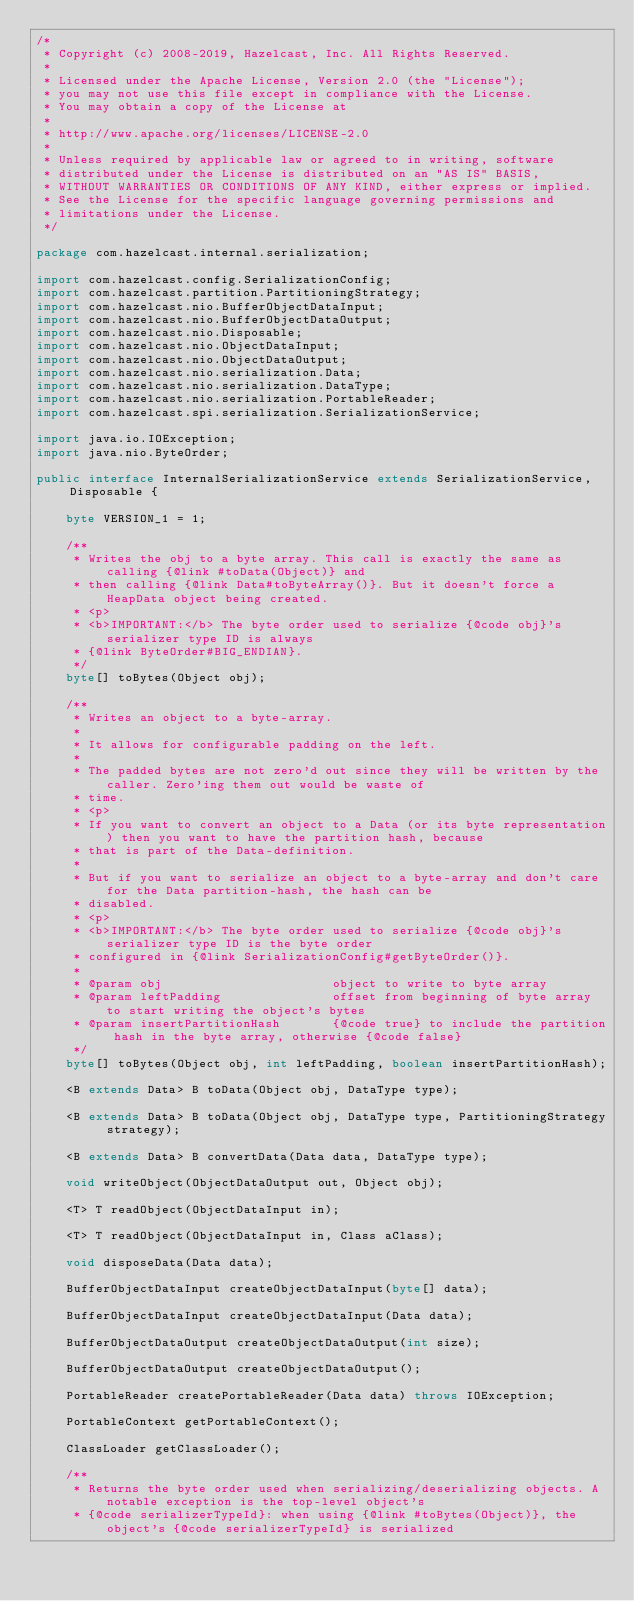Convert code to text. <code><loc_0><loc_0><loc_500><loc_500><_Java_>/*
 * Copyright (c) 2008-2019, Hazelcast, Inc. All Rights Reserved.
 *
 * Licensed under the Apache License, Version 2.0 (the "License");
 * you may not use this file except in compliance with the License.
 * You may obtain a copy of the License at
 *
 * http://www.apache.org/licenses/LICENSE-2.0
 *
 * Unless required by applicable law or agreed to in writing, software
 * distributed under the License is distributed on an "AS IS" BASIS,
 * WITHOUT WARRANTIES OR CONDITIONS OF ANY KIND, either express or implied.
 * See the License for the specific language governing permissions and
 * limitations under the License.
 */

package com.hazelcast.internal.serialization;

import com.hazelcast.config.SerializationConfig;
import com.hazelcast.partition.PartitioningStrategy;
import com.hazelcast.nio.BufferObjectDataInput;
import com.hazelcast.nio.BufferObjectDataOutput;
import com.hazelcast.nio.Disposable;
import com.hazelcast.nio.ObjectDataInput;
import com.hazelcast.nio.ObjectDataOutput;
import com.hazelcast.nio.serialization.Data;
import com.hazelcast.nio.serialization.DataType;
import com.hazelcast.nio.serialization.PortableReader;
import com.hazelcast.spi.serialization.SerializationService;

import java.io.IOException;
import java.nio.ByteOrder;

public interface InternalSerializationService extends SerializationService, Disposable {

    byte VERSION_1 = 1;

    /**
     * Writes the obj to a byte array. This call is exactly the same as calling {@link #toData(Object)} and
     * then calling {@link Data#toByteArray()}. But it doesn't force a HeapData object being created.
     * <p>
     * <b>IMPORTANT:</b> The byte order used to serialize {@code obj}'s serializer type ID is always
     * {@link ByteOrder#BIG_ENDIAN}.
     */
    byte[] toBytes(Object obj);

    /**
     * Writes an object to a byte-array.
     *
     * It allows for configurable padding on the left.
     *
     * The padded bytes are not zero'd out since they will be written by the caller. Zero'ing them out would be waste of
     * time.
     * <p>
     * If you want to convert an object to a Data (or its byte representation) then you want to have the partition hash, because
     * that is part of the Data-definition.
     *
     * But if you want to serialize an object to a byte-array and don't care for the Data partition-hash, the hash can be
     * disabled.
     * <p>
     * <b>IMPORTANT:</b> The byte order used to serialize {@code obj}'s serializer type ID is the byte order
     * configured in {@link SerializationConfig#getByteOrder()}.
     *
     * @param obj                       object to write to byte array
     * @param leftPadding               offset from beginning of byte array to start writing the object's bytes
     * @param insertPartitionHash       {@code true} to include the partition hash in the byte array, otherwise {@code false}
     */
    byte[] toBytes(Object obj, int leftPadding, boolean insertPartitionHash);

    <B extends Data> B toData(Object obj, DataType type);

    <B extends Data> B toData(Object obj, DataType type, PartitioningStrategy strategy);

    <B extends Data> B convertData(Data data, DataType type);

    void writeObject(ObjectDataOutput out, Object obj);

    <T> T readObject(ObjectDataInput in);

    <T> T readObject(ObjectDataInput in, Class aClass);

    void disposeData(Data data);

    BufferObjectDataInput createObjectDataInput(byte[] data);

    BufferObjectDataInput createObjectDataInput(Data data);

    BufferObjectDataOutput createObjectDataOutput(int size);

    BufferObjectDataOutput createObjectDataOutput();

    PortableReader createPortableReader(Data data) throws IOException;

    PortableContext getPortableContext();

    ClassLoader getClassLoader();

    /**
     * Returns the byte order used when serializing/deserializing objects. A notable exception is the top-level object's
     * {@code serializerTypeId}: when using {@link #toBytes(Object)}, the object's {@code serializerTypeId} is serialized</code> 